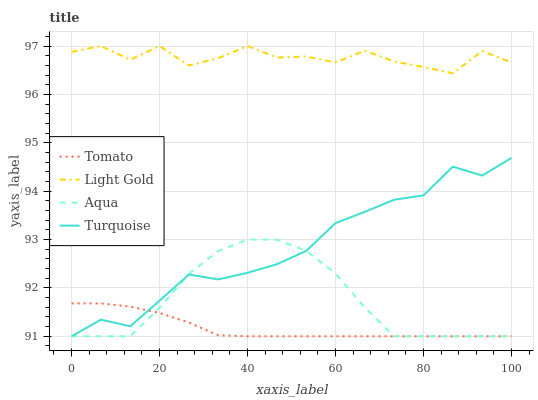Does Tomato have the minimum area under the curve?
Answer yes or no. Yes. Does Light Gold have the maximum area under the curve?
Answer yes or no. Yes. Does Aqua have the minimum area under the curve?
Answer yes or no. No. Does Aqua have the maximum area under the curve?
Answer yes or no. No. Is Tomato the smoothest?
Answer yes or no. Yes. Is Light Gold the roughest?
Answer yes or no. Yes. Is Aqua the smoothest?
Answer yes or no. No. Is Aqua the roughest?
Answer yes or no. No. Does Light Gold have the lowest value?
Answer yes or no. No. Does Light Gold have the highest value?
Answer yes or no. Yes. Does Aqua have the highest value?
Answer yes or no. No. Is Turquoise less than Light Gold?
Answer yes or no. Yes. Is Light Gold greater than Tomato?
Answer yes or no. Yes. Does Tomato intersect Turquoise?
Answer yes or no. Yes. Is Tomato less than Turquoise?
Answer yes or no. No. Is Tomato greater than Turquoise?
Answer yes or no. No. Does Turquoise intersect Light Gold?
Answer yes or no. No. 